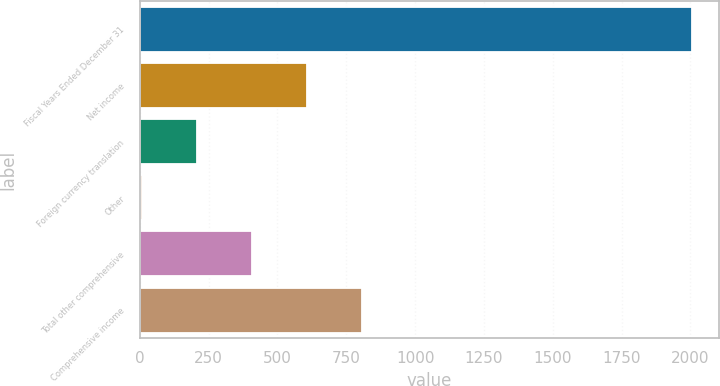Convert chart. <chart><loc_0><loc_0><loc_500><loc_500><bar_chart><fcel>Fiscal Years Ended December 31<fcel>Net income<fcel>Foreign currency translation<fcel>Other<fcel>Total other comprehensive<fcel>Comprehensive income<nl><fcel>2004<fcel>606.1<fcel>206.7<fcel>7<fcel>406.4<fcel>805.8<nl></chart> 